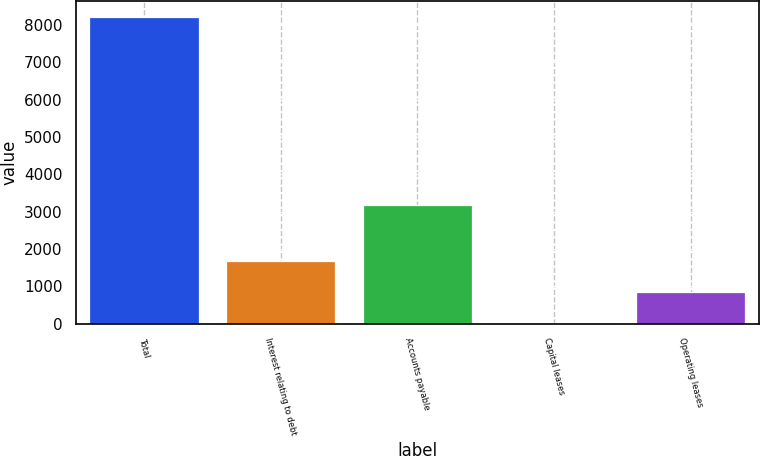Convert chart to OTSL. <chart><loc_0><loc_0><loc_500><loc_500><bar_chart><fcel>Total<fcel>Interest relating to debt<fcel>Accounts payable<fcel>Capital leases<fcel>Operating leases<nl><fcel>8231<fcel>1668.6<fcel>3184<fcel>28<fcel>848.3<nl></chart> 